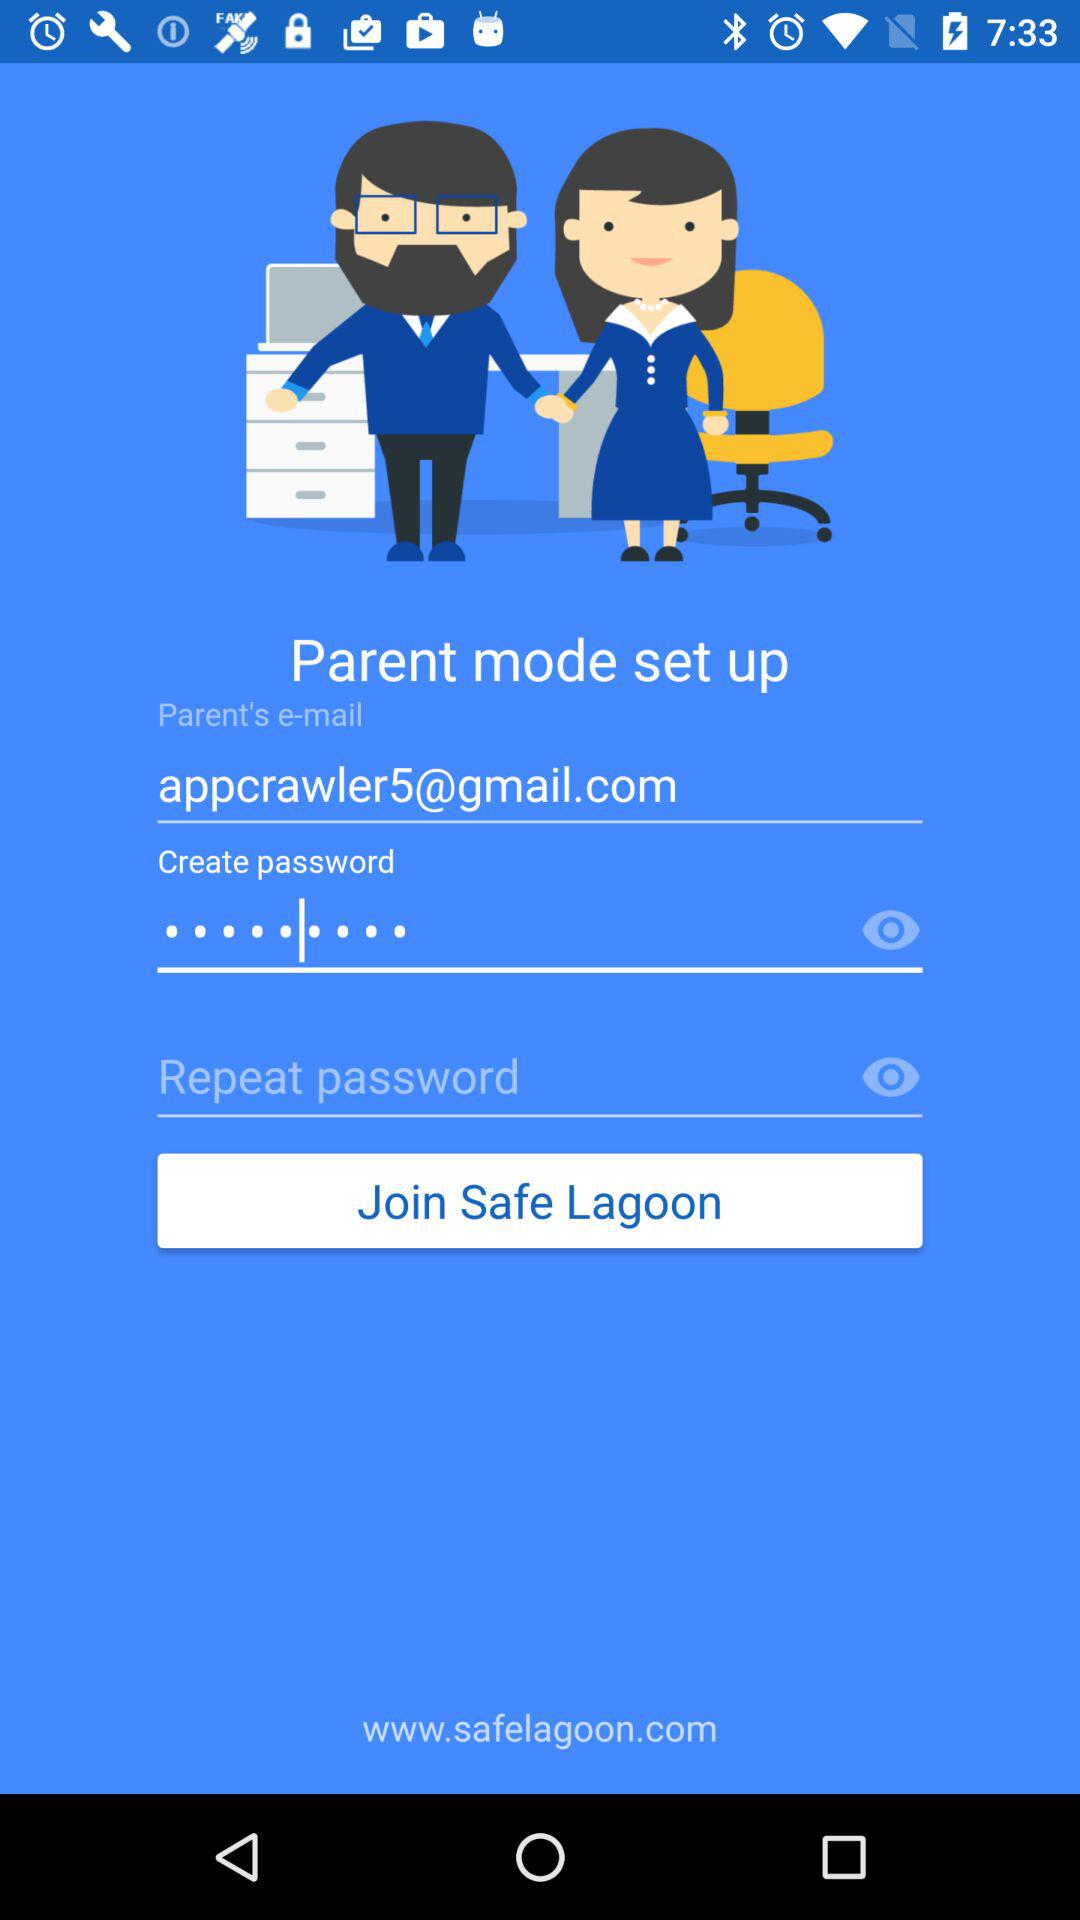What is the email address of the parent? The email address is appcrawler5@gmail.com. 